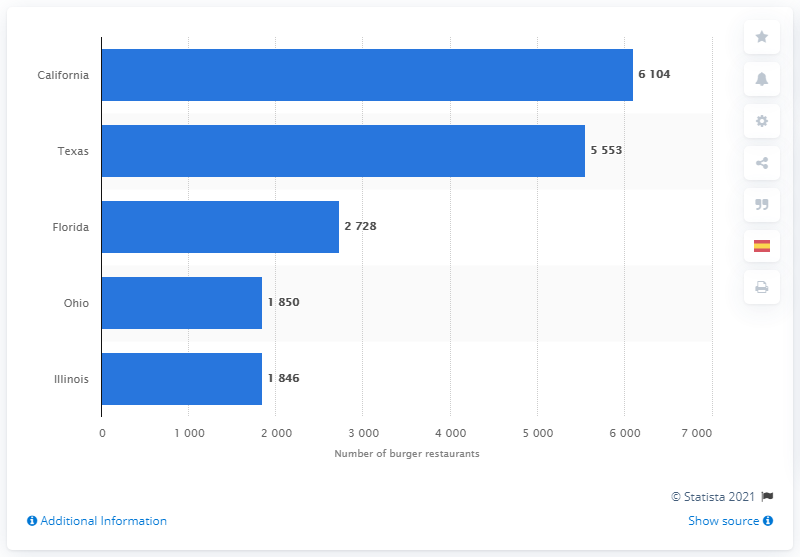Give some essential details in this illustration. In June 2014, Texas had the highest number of burger restaurants. 